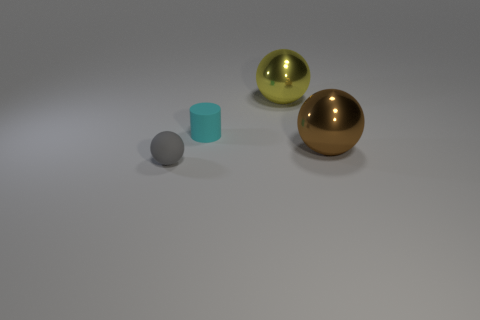Add 2 gray things. How many objects exist? 6 Subtract all cyan cubes. How many yellow balls are left? 1 Subtract all big objects. Subtract all brown shiny spheres. How many objects are left? 1 Add 4 yellow metal things. How many yellow metal things are left? 5 Add 2 brown balls. How many brown balls exist? 3 Subtract all gray spheres. How many spheres are left? 2 Subtract all gray spheres. How many spheres are left? 2 Subtract 0 red cylinders. How many objects are left? 4 Subtract all balls. How many objects are left? 1 Subtract 2 spheres. How many spheres are left? 1 